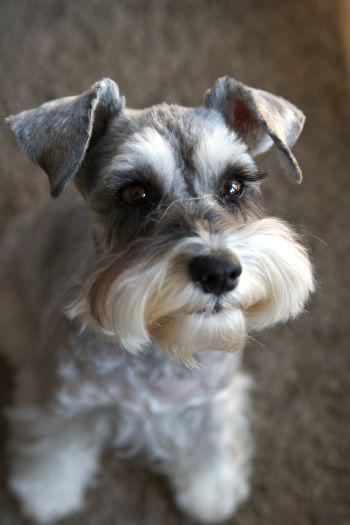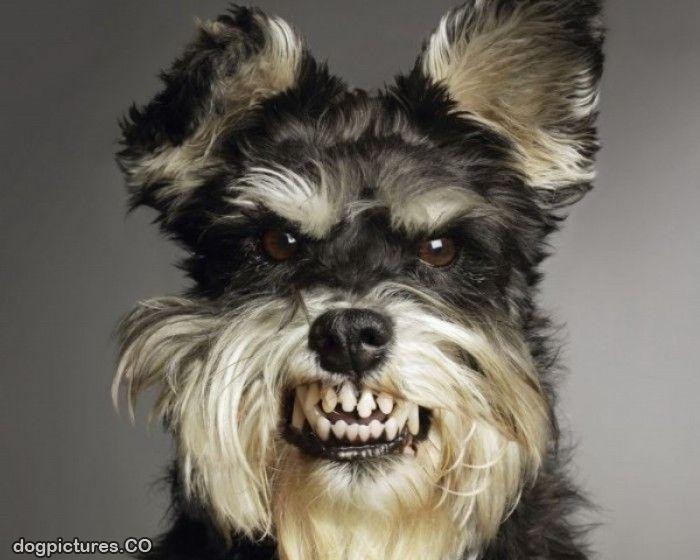The first image is the image on the left, the second image is the image on the right. For the images shown, is this caption "An image shows an animal with all-white fur." true? Answer yes or no. No. 